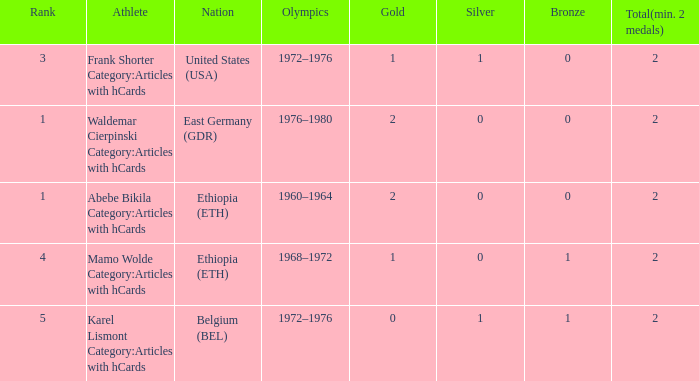What is the least amount of total medals won? 2.0. 